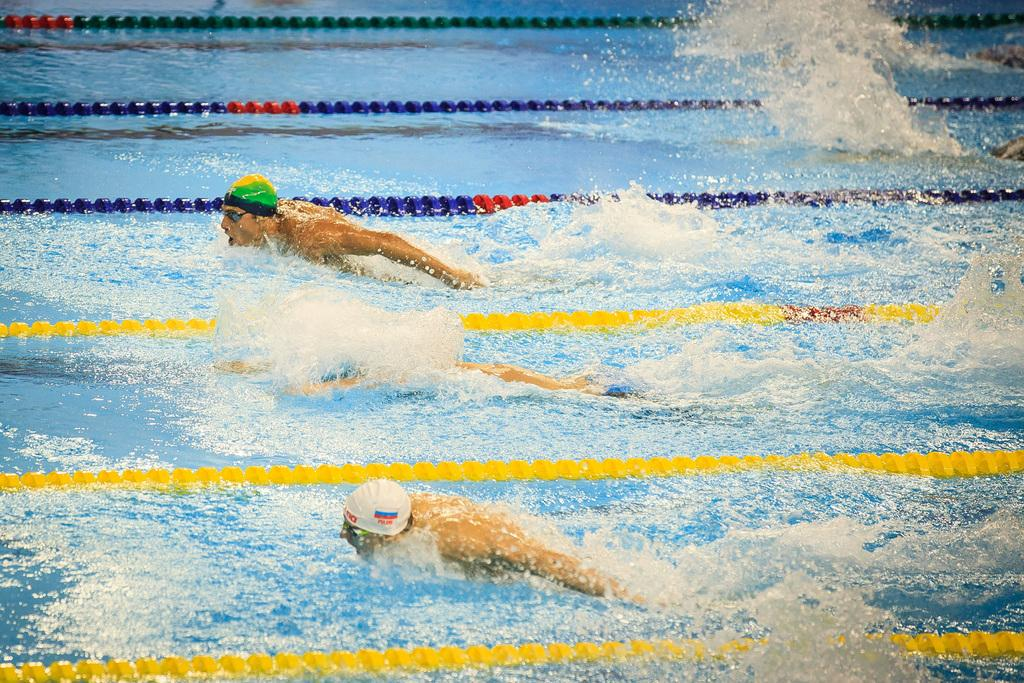What are the three persons in the image doing? The three persons in the image are swimming in the water. What protective gear are the persons on the sides wearing? The persons on the sides are wearing caps and goggles. What can be seen in the water besides the swimmers? There are ropes in the water. What type of soap is being used by the crowd in the image? There is no crowd present in the image, and therefore no soap can be observed. What is the value of the swimming event in the image? There is no indication of a swimming event or any value associated with it in the image. 